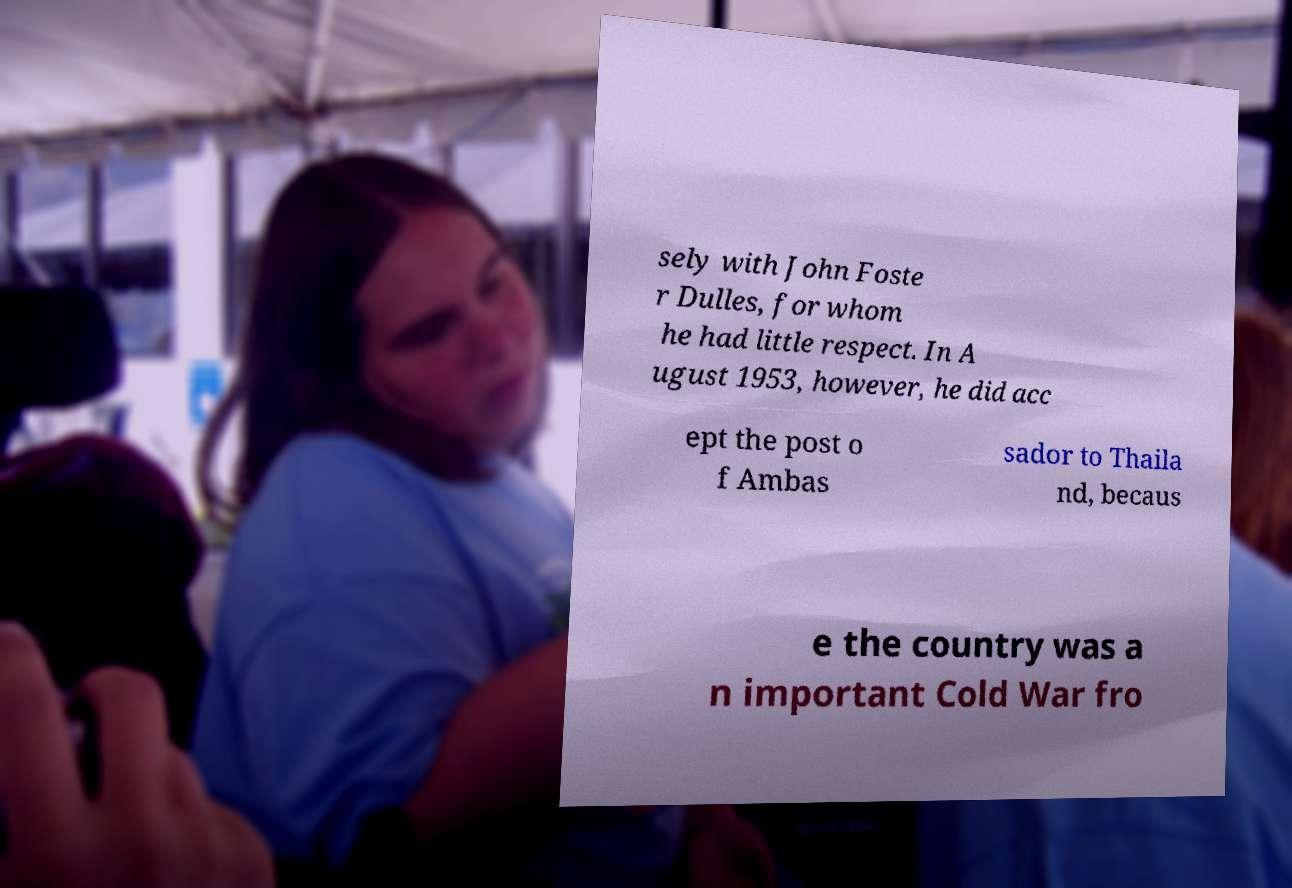Could you extract and type out the text from this image? sely with John Foste r Dulles, for whom he had little respect. In A ugust 1953, however, he did acc ept the post o f Ambas sador to Thaila nd, becaus e the country was a n important Cold War fro 